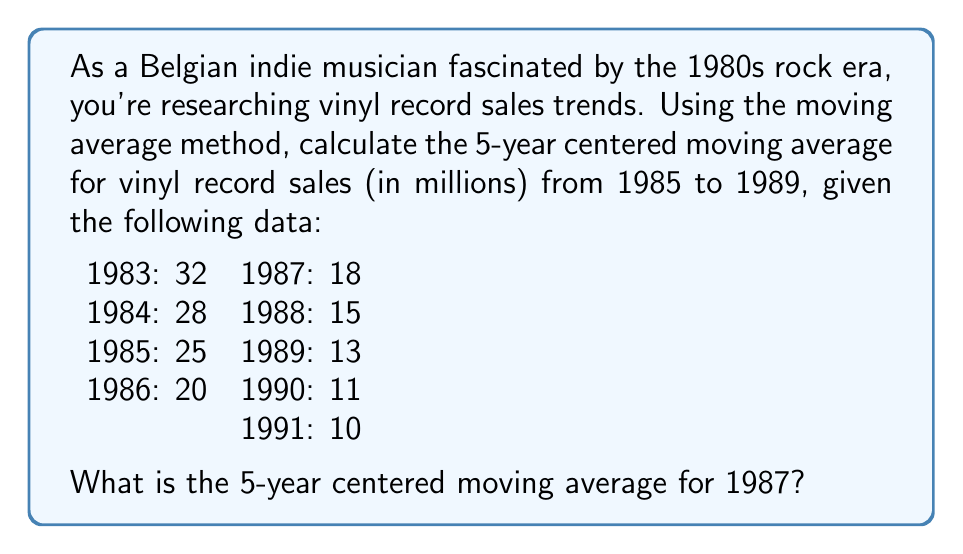Provide a solution to this math problem. To calculate the 5-year centered moving average for 1987, we'll follow these steps:

1. Identify the relevant data points:
   1985: 25
   1986: 20
   1987: 18
   1988: 15
   1989: 13

2. Calculate the sum of these five years:
   $$ \text{Sum} = 25 + 20 + 18 + 15 + 13 = 91 $$

3. Divide the sum by 5 to get the moving average:
   $$ \text{Moving Average} = \frac{91}{5} = 18.2 $$

The formula for the 5-year centered moving average is:

$$ MA_t = \frac{Y_{t-2} + Y_{t-1} + Y_t + Y_{t+1} + Y_{t+2}}{5} $$

Where $MA_t$ is the moving average for year $t$, and $Y_t$ represents the value for year $t$.

For 1987:
$$ MA_{1987} = \frac{25 + 20 + 18 + 15 + 13}{5} = 18.2 $$

This method helps smooth out short-term fluctuations and highlight longer-term trends in the vinyl record sales data, which is particularly relevant for analyzing the decline of vinyl sales during the transition from the vinyl-dominated 1980s to the CD-dominated 1990s.
Answer: The 5-year centered moving average for vinyl record sales in 1987 is 18.2 million. 